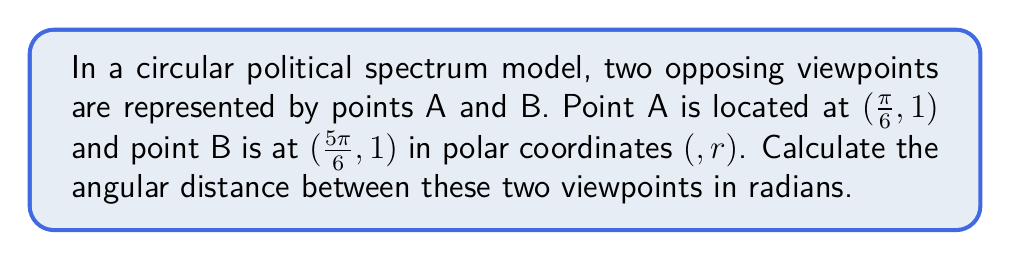Help me with this question. To solve this problem, we need to follow these steps:

1) In a circular political spectrum, the angular distance between two points is the absolute difference between their angular coordinates.

2) The angular coordinates of the two points are:
   Point A: $θ_A = \frac{\pi}{6}$
   Point B: $θ_B = \frac{5\pi}{6}$

3) The angular distance is given by:
   $|θ_B - θ_A|$

4) Substituting the values:
   $|\frac{5\pi}{6} - \frac{\pi}{6}|$

5) Simplifying:
   $|\frac{4\pi}{6}|$

6) Simplifying further:
   $\frac{2\pi}{3}$

7) Note: In a circular model, the maximum angular distance is $\pi$ radians (180°). If the calculated difference is greater than $\pi$, we need to subtract it from $2\pi$ to get the shorter arc. However, in this case, $\frac{2\pi}{3}$ is less than $\pi$, so it's already the shortest distance.

[asy]
import geometry;

unitcircle();
dot("A", dir(30), NE);
dot("B", dir(150), NW);
draw(arc(0,1,30,150), Arrow);
label("$\frac{2\pi}{3}$", (0.5,0.5), N);
[/asy]

This angular distance represents the degree of difference between the two political viewpoints on the circular spectrum.
Answer: $\frac{2\pi}{3}$ radians 